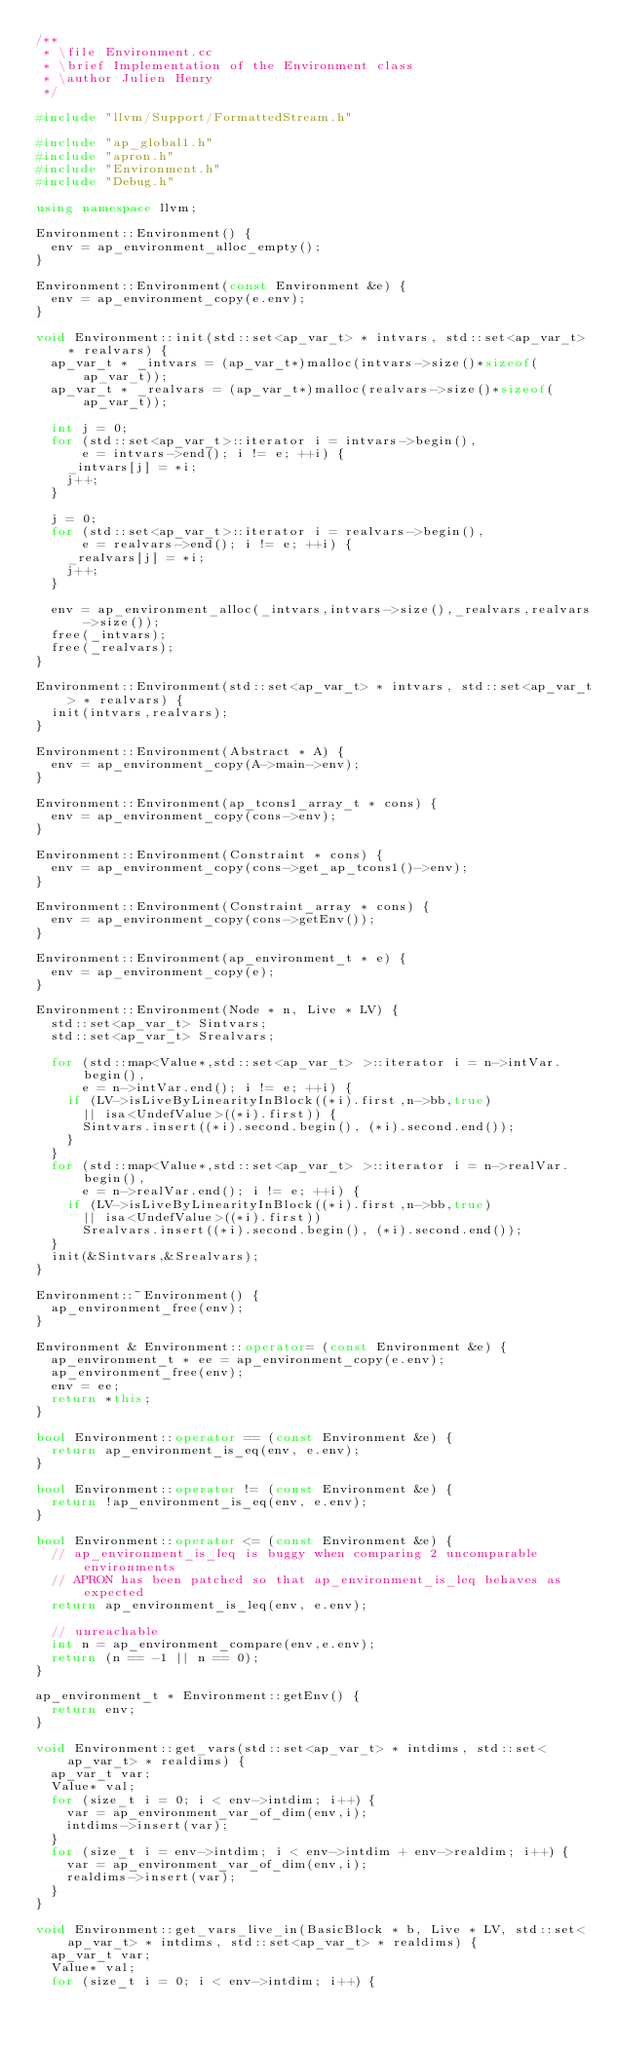Convert code to text. <code><loc_0><loc_0><loc_500><loc_500><_C++_>/**
 * \file Environment.cc
 * \brief Implementation of the Environment class
 * \author Julien Henry
 */

#include "llvm/Support/FormattedStream.h"

#include "ap_global1.h"
#include "apron.h"
#include "Environment.h"
#include "Debug.h"

using namespace llvm;

Environment::Environment() {
	env = ap_environment_alloc_empty();
}
 
Environment::Environment(const Environment &e) {
	env = ap_environment_copy(e.env);
}

void Environment::init(std::set<ap_var_t> * intvars, std::set<ap_var_t> * realvars) {
	ap_var_t * _intvars = (ap_var_t*)malloc(intvars->size()*sizeof(ap_var_t));
	ap_var_t * _realvars = (ap_var_t*)malloc(realvars->size()*sizeof(ap_var_t));

	int j = 0;
	for (std::set<ap_var_t>::iterator i = intvars->begin(),
			e = intvars->end(); i != e; ++i) {
		_intvars[j] = *i;
		j++;
	}

	j = 0;
	for (std::set<ap_var_t>::iterator i = realvars->begin(),
			e = realvars->end(); i != e; ++i) {
		_realvars[j] = *i;
		j++;
	}

	env = ap_environment_alloc(_intvars,intvars->size(),_realvars,realvars->size());
	free(_intvars);
	free(_realvars);
}

Environment::Environment(std::set<ap_var_t> * intvars, std::set<ap_var_t> * realvars) {
	init(intvars,realvars);
}

Environment::Environment(Abstract * A) {
	env = ap_environment_copy(A->main->env);
}

Environment::Environment(ap_tcons1_array_t * cons) {
	env = ap_environment_copy(cons->env);
}

Environment::Environment(Constraint * cons) {
	env = ap_environment_copy(cons->get_ap_tcons1()->env);
}

Environment::Environment(Constraint_array * cons) {
	env = ap_environment_copy(cons->getEnv());
}

Environment::Environment(ap_environment_t * e) {
	env = ap_environment_copy(e);
}
		
Environment::Environment(Node * n, Live * LV) {
	std::set<ap_var_t> Sintvars;
	std::set<ap_var_t> Srealvars;

	for (std::map<Value*,std::set<ap_var_t> >::iterator i = n->intVar.begin(),
			e = n->intVar.end(); i != e; ++i) {
		if (LV->isLiveByLinearityInBlock((*i).first,n->bb,true)
			|| isa<UndefValue>((*i).first)) {
			Sintvars.insert((*i).second.begin(), (*i).second.end());
		}
	}
	for (std::map<Value*,std::set<ap_var_t> >::iterator i = n->realVar.begin(),
			e = n->realVar.end(); i != e; ++i) {
		if (LV->isLiveByLinearityInBlock((*i).first,n->bb,true)
			|| isa<UndefValue>((*i).first))
			Srealvars.insert((*i).second.begin(), (*i).second.end());
	}
	init(&Sintvars,&Srealvars);
}

Environment::~Environment() {
	ap_environment_free(env);
}

Environment & Environment::operator= (const Environment &e) {
	ap_environment_t * ee = ap_environment_copy(e.env);
	ap_environment_free(env);
	env = ee;
	return *this;
}
		
bool Environment::operator == (const Environment &e) {
	return ap_environment_is_eq(env, e.env);
}

bool Environment::operator != (const Environment &e) {
	return !ap_environment_is_eq(env, e.env);
}

bool Environment::operator <= (const Environment &e) {
	// ap_environment_is_leq is buggy when comparing 2 uncomparable environments
	// APRON has been patched so that ap_environment_is_leq behaves as expected
	return ap_environment_is_leq(env, e.env);

	// unreachable
	int n = ap_environment_compare(env,e.env);
	return (n == -1 || n == 0);
}

ap_environment_t * Environment::getEnv() {
	return env;
}

void Environment::get_vars(std::set<ap_var_t> * intdims, std::set<ap_var_t> * realdims) {
	ap_var_t var;
	Value* val;
	for (size_t i = 0; i < env->intdim; i++) {
		var = ap_environment_var_of_dim(env,i);
		intdims->insert(var);
	}
	for (size_t i = env->intdim; i < env->intdim + env->realdim; i++) {
		var = ap_environment_var_of_dim(env,i);
		realdims->insert(var);
	}
}

void Environment::get_vars_live_in(BasicBlock * b, Live * LV, std::set<ap_var_t> * intdims, std::set<ap_var_t> * realdims) {
	ap_var_t var;
	Value* val;
	for (size_t i = 0; i < env->intdim; i++) {</code> 